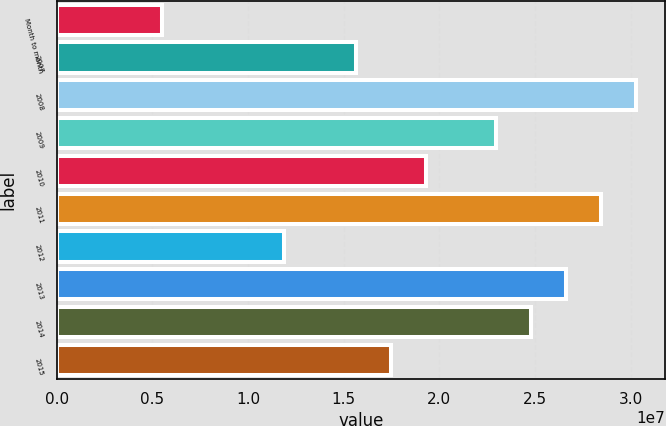Convert chart. <chart><loc_0><loc_0><loc_500><loc_500><bar_chart><fcel>Month to month<fcel>2007<fcel>2008<fcel>2009<fcel>2010<fcel>2011<fcel>2012<fcel>2013<fcel>2014<fcel>2015<nl><fcel>5.502e+06<fcel>1.5636e+07<fcel>3.02664e+07<fcel>2.29512e+07<fcel>1.92936e+07<fcel>2.84376e+07<fcel>1.1864e+07<fcel>2.66088e+07<fcel>2.478e+07<fcel>1.74648e+07<nl></chart> 